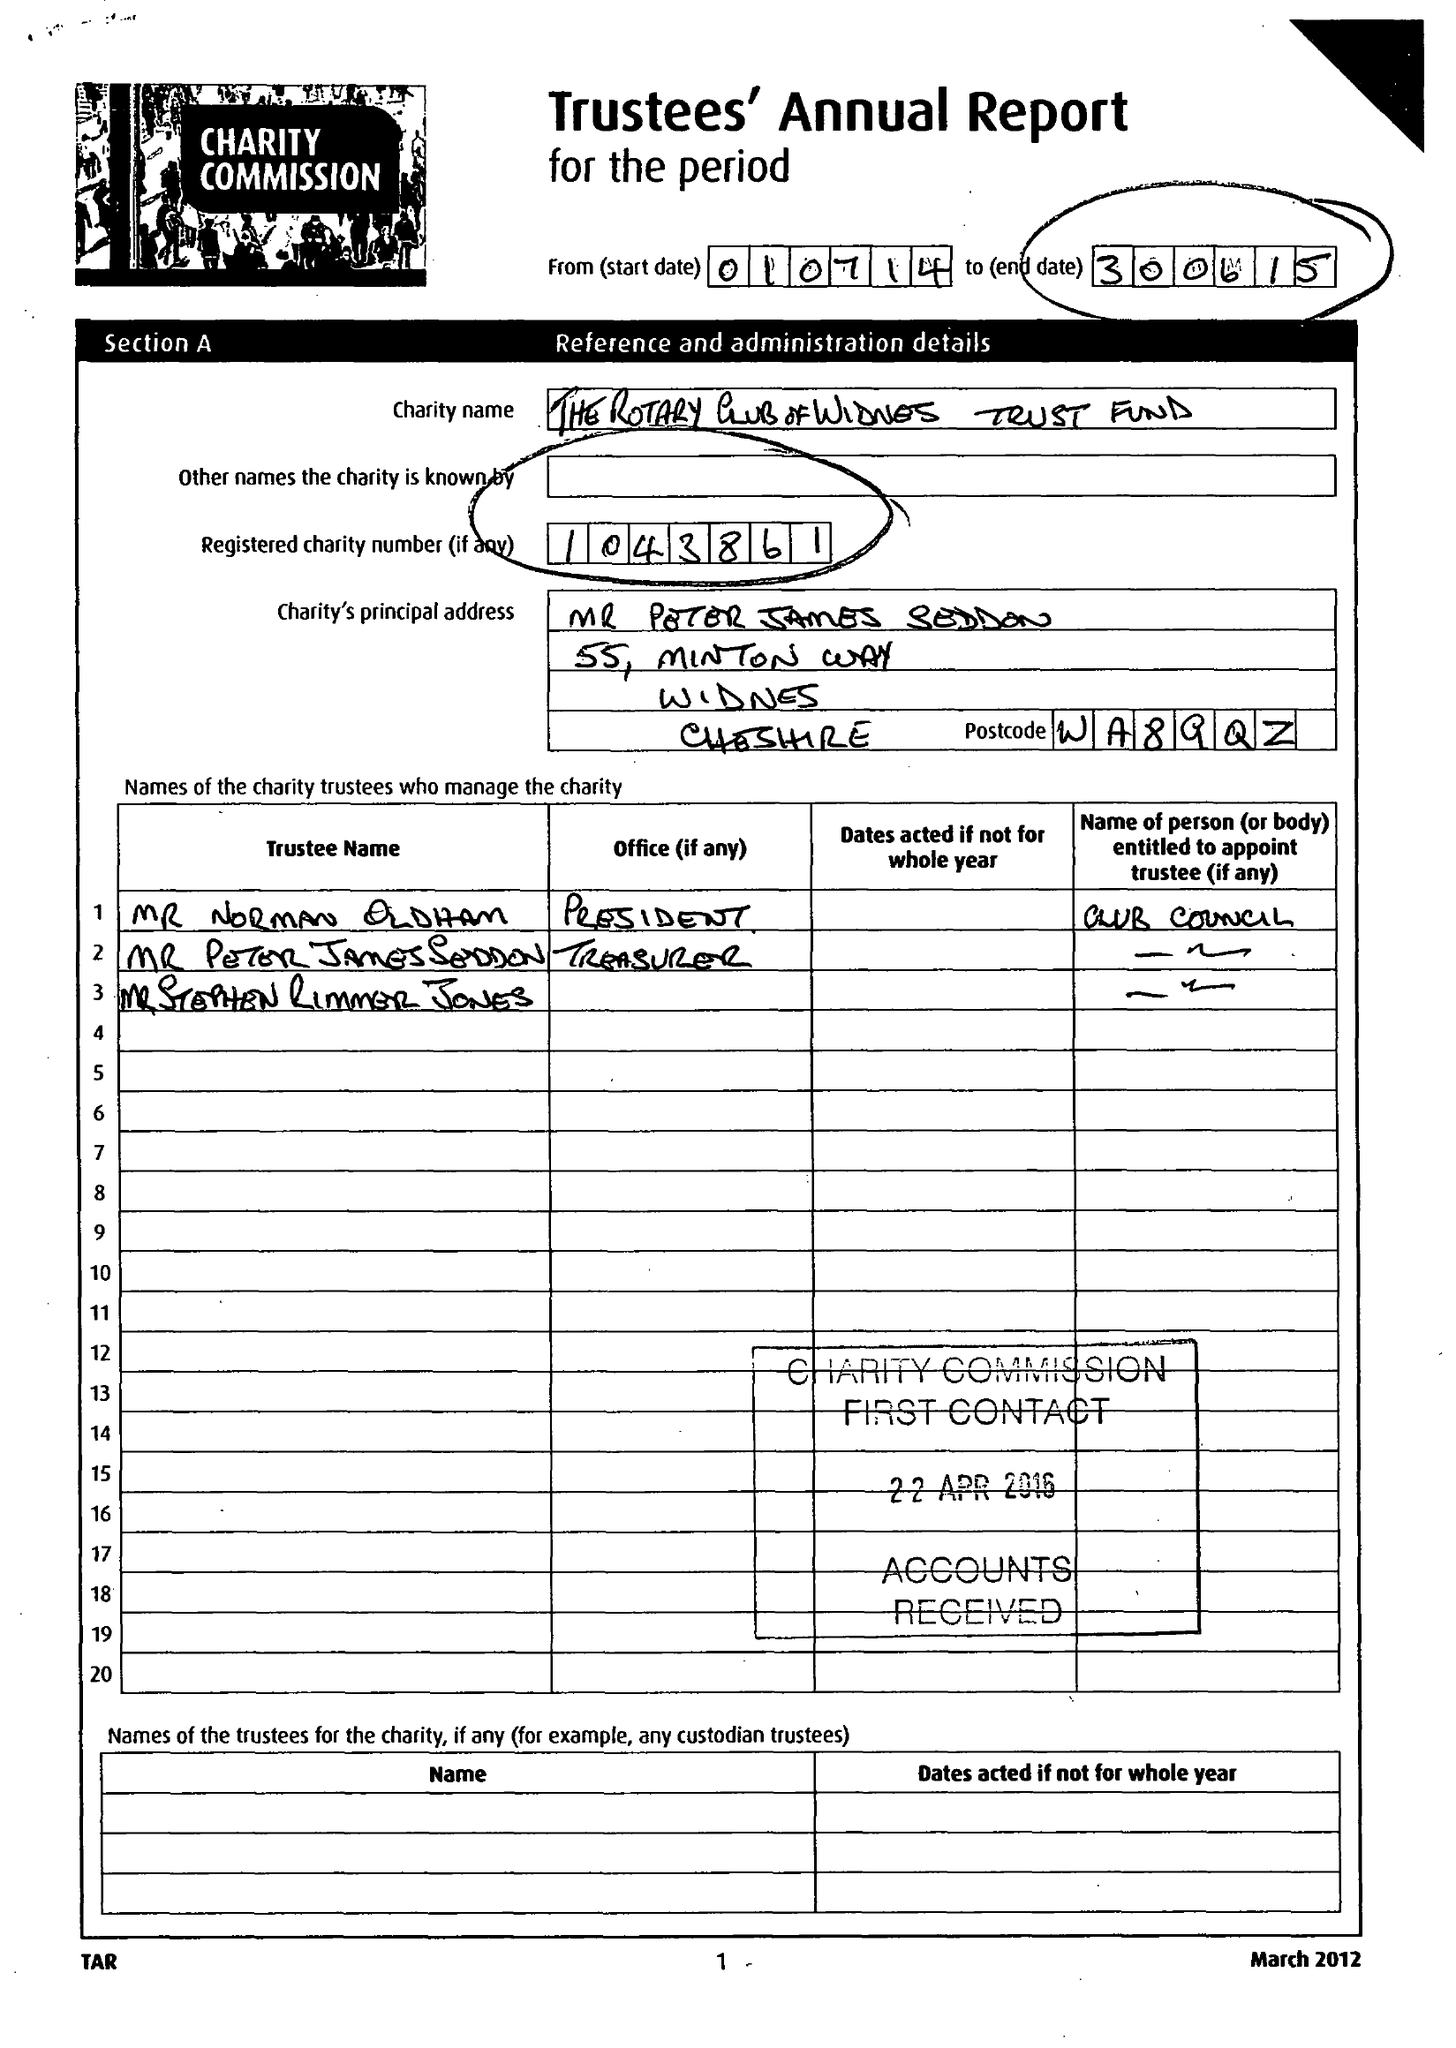What is the value for the address__postcode?
Answer the question using a single word or phrase. WA8 9GR 